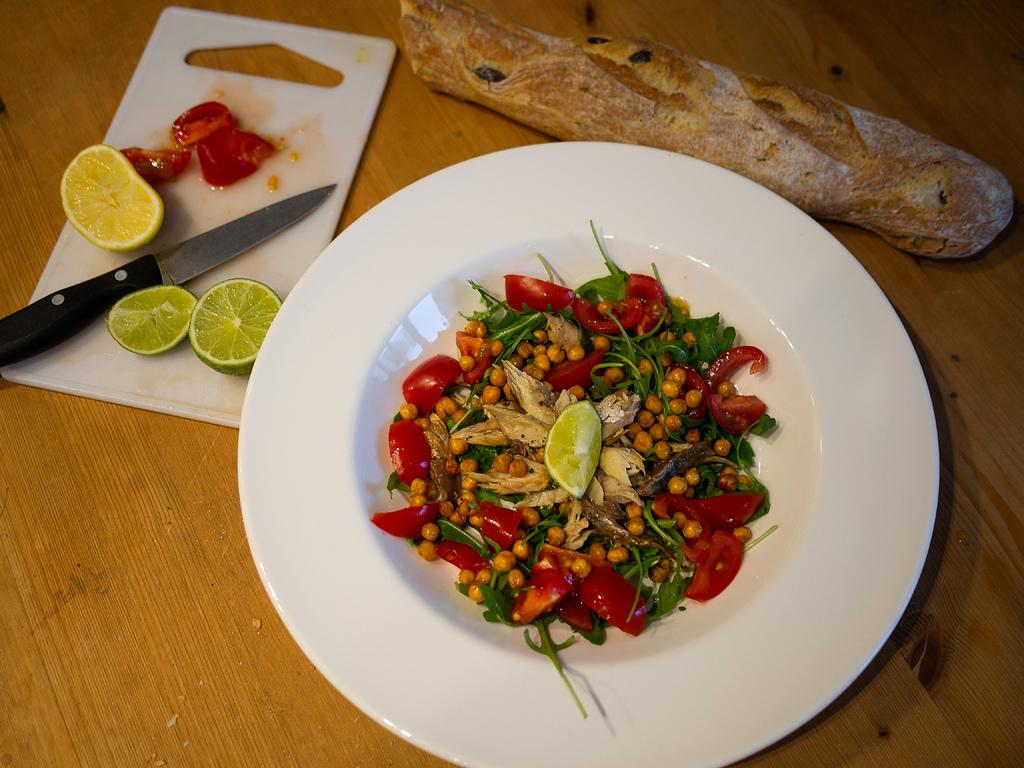What type of fruits are present in the image? There are lemons and tomatoes in the image. What other type of food is present in the image? There are peanuts in the image. Where are these items located? These items are on a plate. What utensil can be seen in the image? There is a knife visible in the image. What is the surface made of that the plate is on? The items are on a wooden surface. What song are the rabbits singing in the image? There are no rabbits or singing present in the image. Who is the brother of the person holding the plate in the image? There is no person holding the plate in the image, and therefore no brother can be identified. 